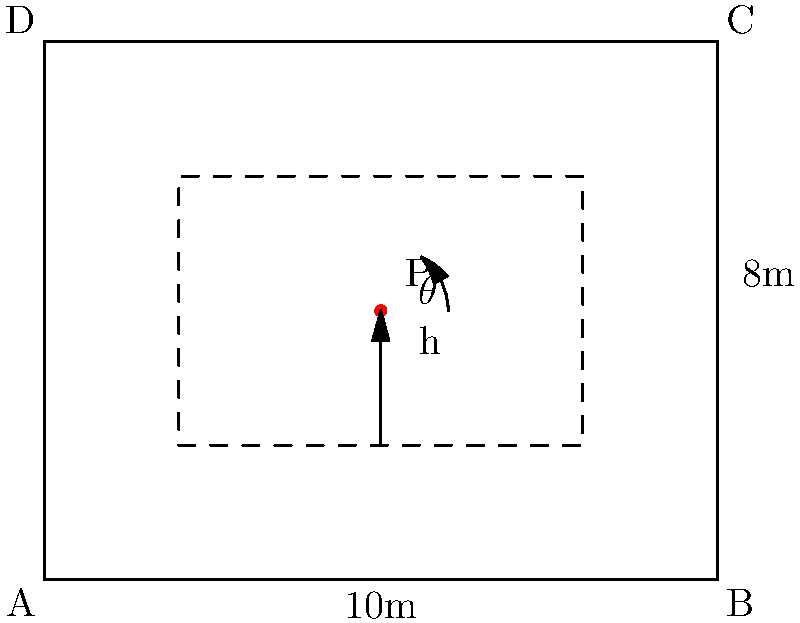In a Kubernetes cluster, you need to determine the optimal placement of storage volumes in a data center. The data center floor is represented as a rectangle measuring 10m x 8m. A storage rack is placed 2m from the left wall and 2m from the bottom wall, extending 6m in width and 4m in height. The optimal placement point P is located at the center of the rack. If the angle $\theta$ between the horizontal and the line from the bottom-left corner of the data center to point P is 53°, what is the height (h) of point P from the bottom of the data center? To solve this problem, we'll use the tangent trigonometric ratio. Here's a step-by-step approach:

1) First, let's identify the known variables:
   - The angle $\theta$ is 53°
   - The horizontal distance from the bottom-left corner (A) to the vertical line through P is 5m (half of the 10m width)

2) We can form a right triangle with the following components:
   - The hypotenuse is the line from A to P
   - The adjacent side is the horizontal distance from A to the vertical line through P (5m)
   - The opposite side is the height we're trying to find (h)

3) The tangent ratio relates the opposite and adjacent sides of a right triangle:

   $$\tan(\theta) = \frac{\text{opposite}}{\text{adjacent}} = \frac{h}{5}$$

4) We can rearrange this to solve for h:

   $$h = 5 \tan(53°)$$

5) Using a calculator or trigonometric table:

   $$h = 5 \times 1.3270 = 6.635\text{ m}$$

6) Rounding to two decimal places:

   $$h \approx 6.64\text{ m}$$

This height represents the distance from the bottom of the data center to the optimal placement point P.
Answer: 6.64 m 